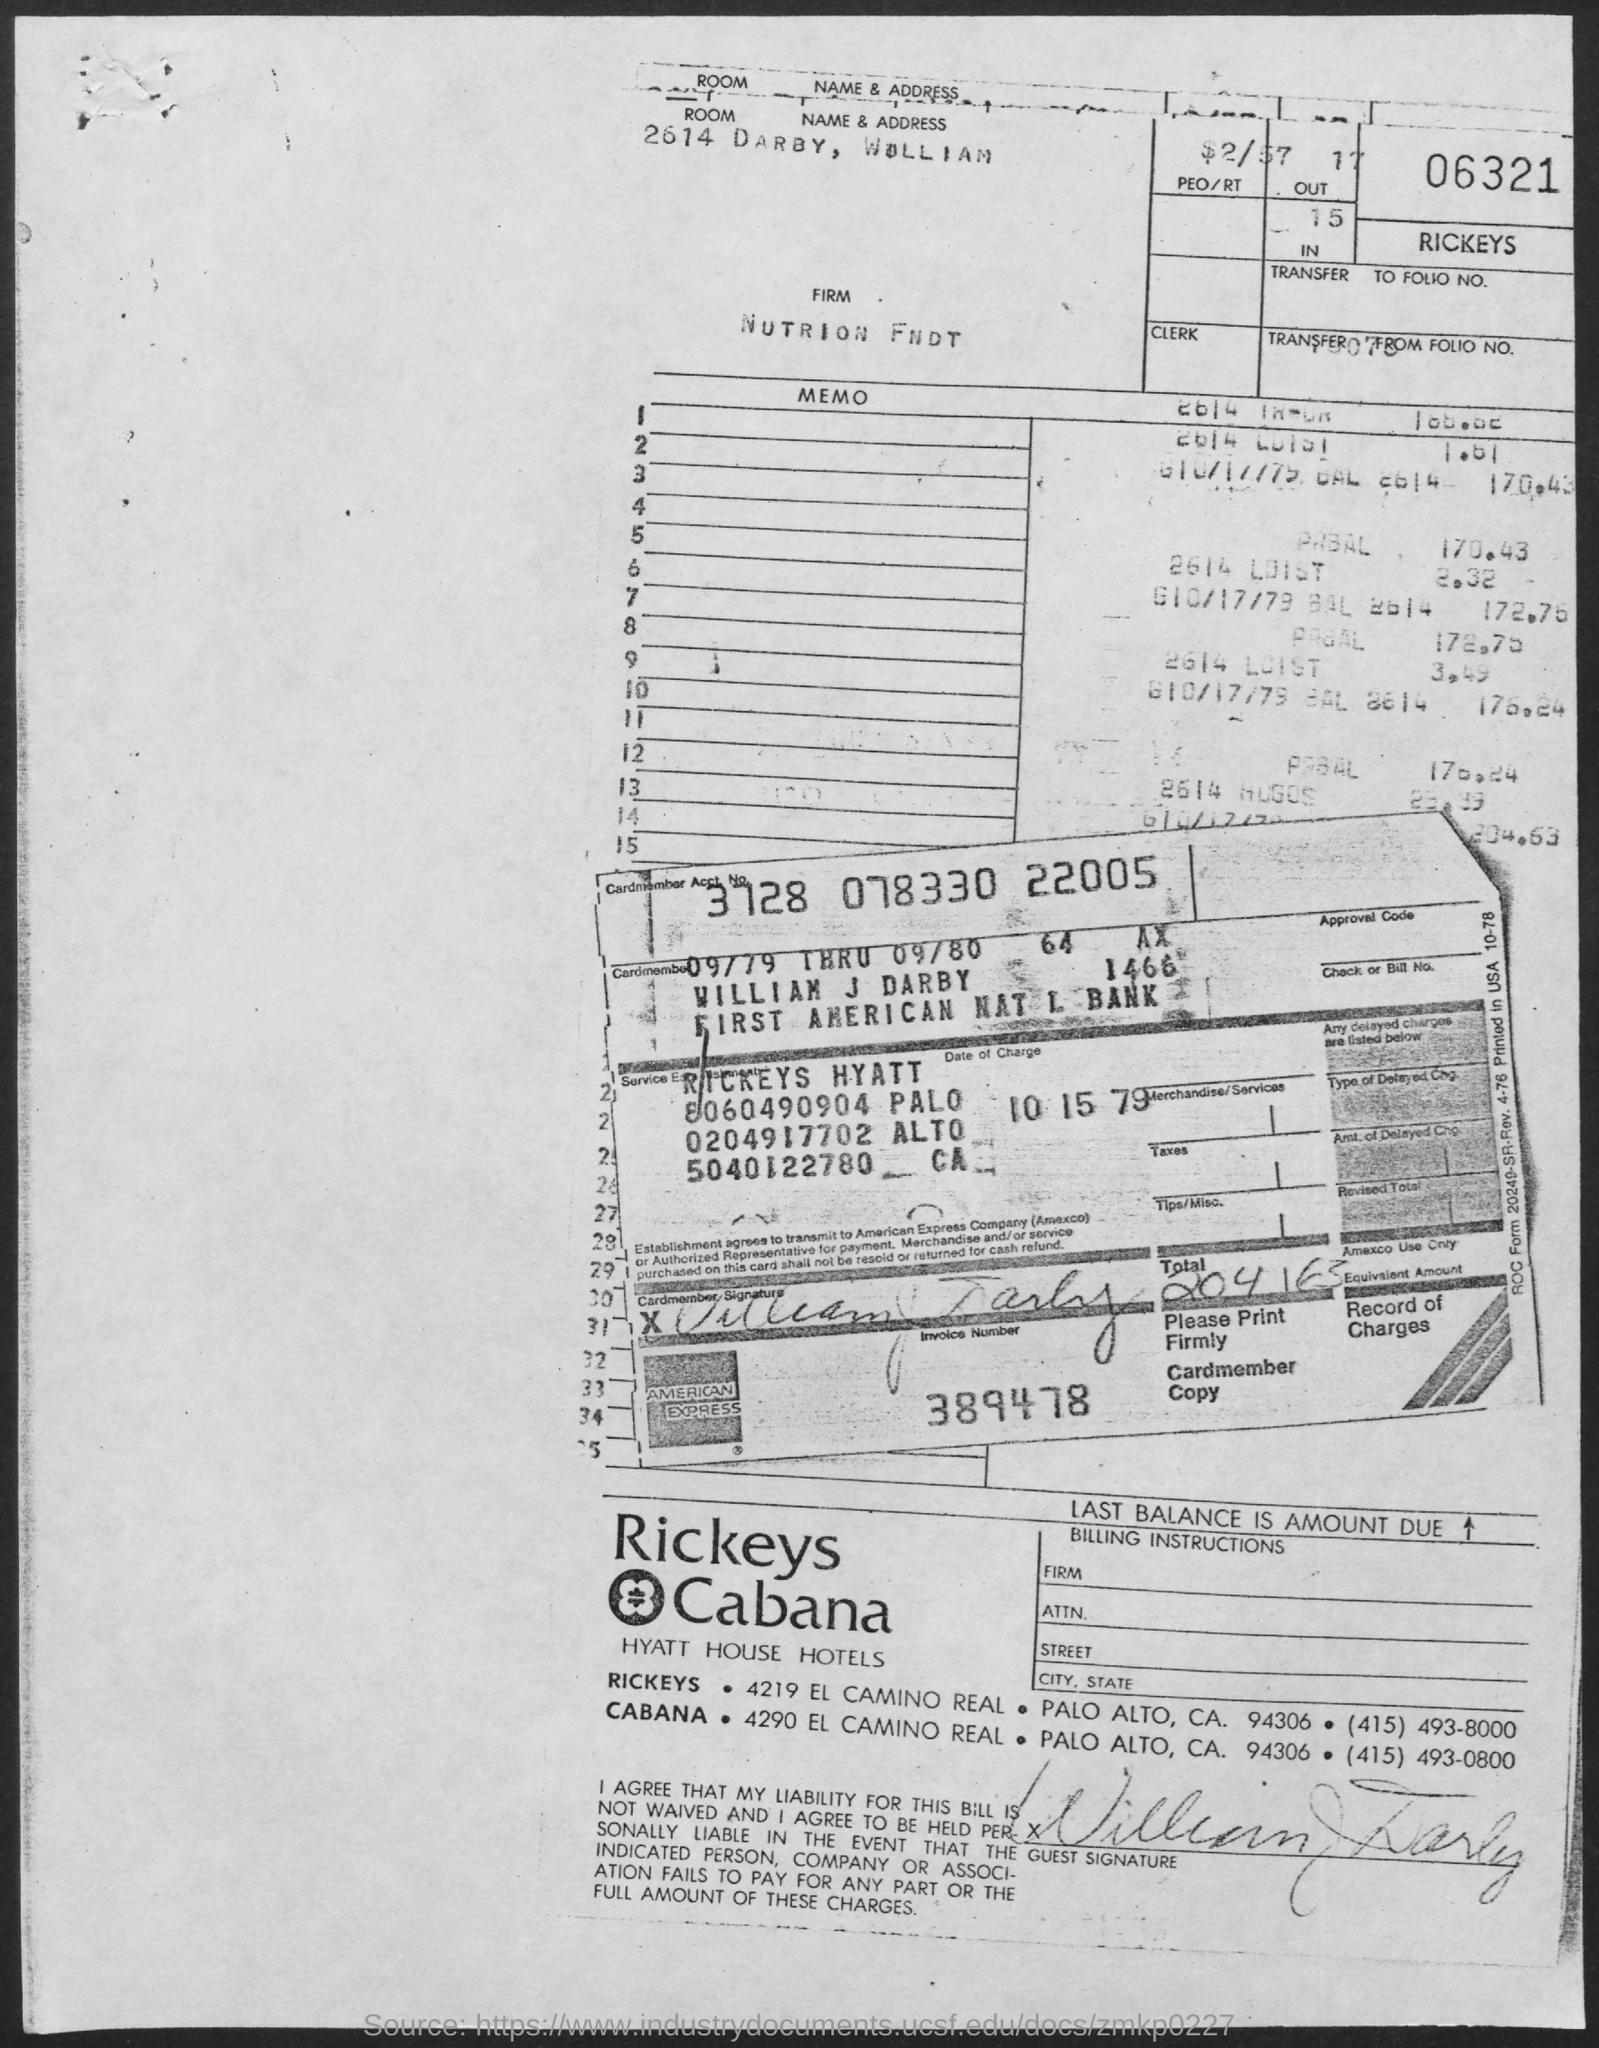Specify some key components in this picture. What is the date of charge for the case number 101579? The invoice number is 389478. Please provide the account number of the cardmember as 3728 078330 22005. CABANA's contact number is (415) 493-0800. The room number is 2614. 